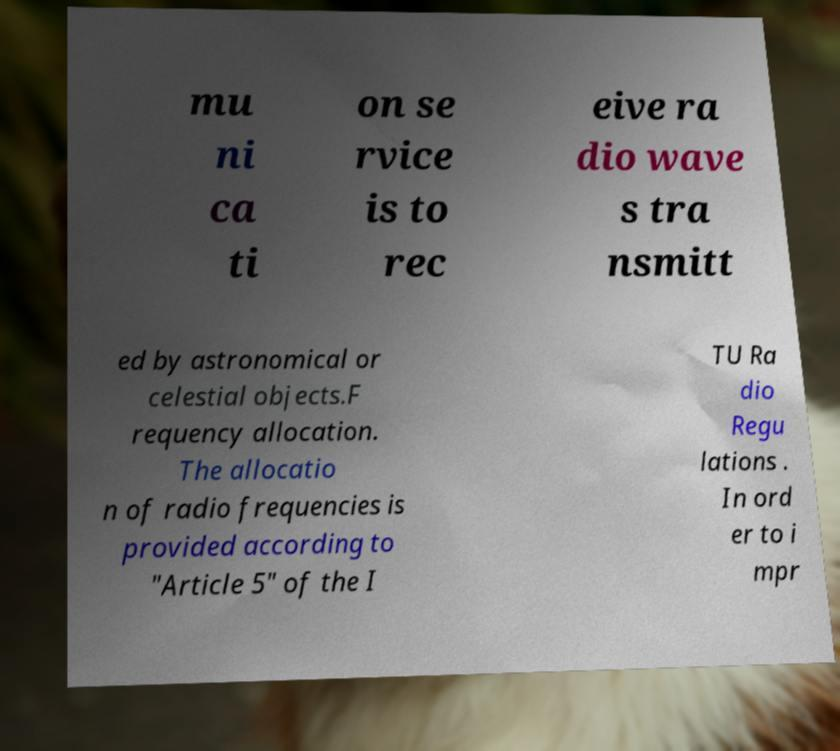Please read and relay the text visible in this image. What does it say? mu ni ca ti on se rvice is to rec eive ra dio wave s tra nsmitt ed by astronomical or celestial objects.F requency allocation. The allocatio n of radio frequencies is provided according to "Article 5" of the I TU Ra dio Regu lations . In ord er to i mpr 